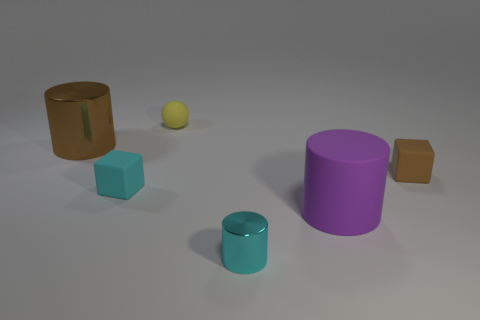Do the tiny brown block and the cyan thing that is behind the large matte cylinder have the same material?
Offer a very short reply. Yes. How many things are red blocks or small things that are on the left side of the tiny brown cube?
Your response must be concise. 3. There is a brown object on the left side of the big rubber cylinder; is it the same size as the cylinder that is on the right side of the tiny shiny object?
Make the answer very short. Yes. What number of other things are the same color as the rubber ball?
Provide a succinct answer. 0. Is the size of the purple thing the same as the brown object that is on the left side of the large purple rubber cylinder?
Your response must be concise. Yes. What size is the brown object that is to the left of the purple matte cylinder to the right of the yellow thing?
Make the answer very short. Large. What color is the other shiny object that is the same shape as the big metal object?
Ensure brevity in your answer.  Cyan. Is the yellow object the same size as the purple cylinder?
Your response must be concise. No. Are there the same number of large purple things that are to the left of the small cyan cylinder and large matte cubes?
Provide a short and direct response. Yes. Is there a tiny brown thing that is behind the small thing in front of the purple matte cylinder?
Give a very brief answer. Yes. 